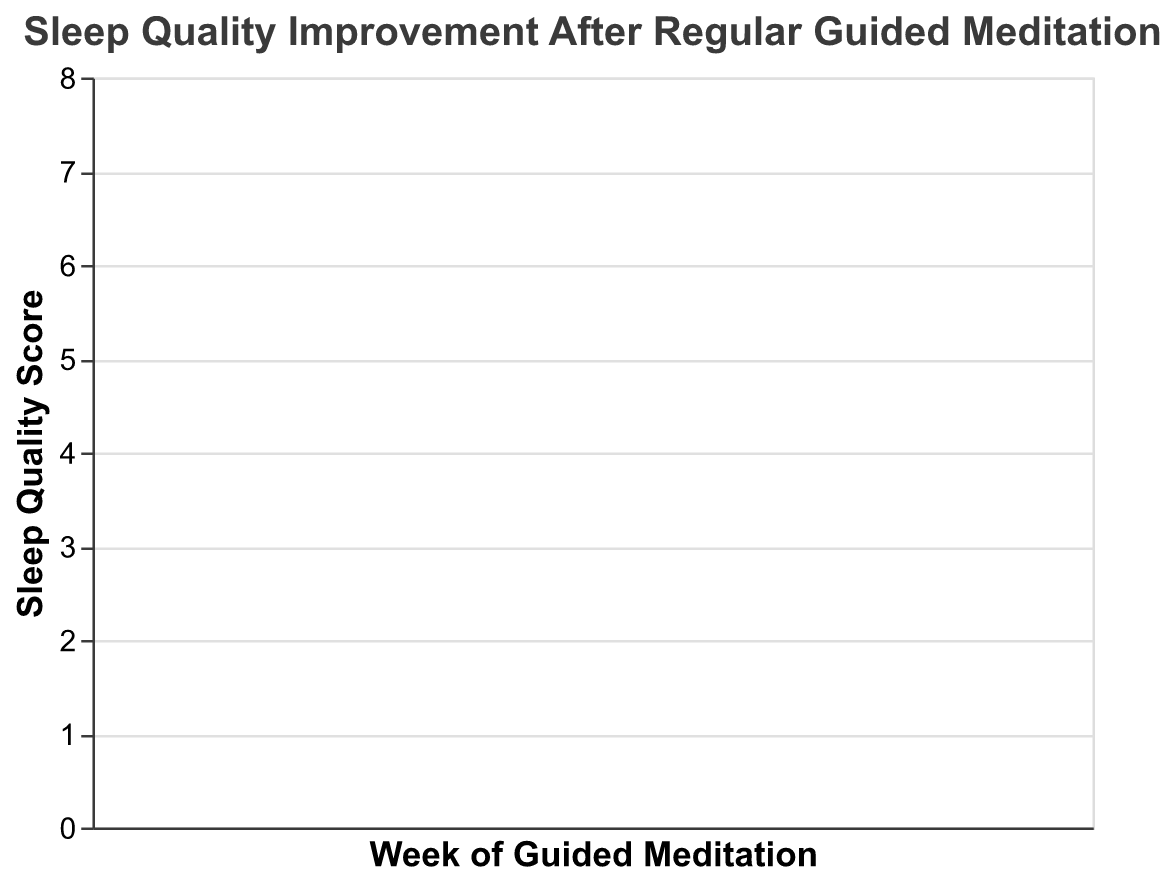What is the title of the figure? Look at the top of the figure. The title is given there.
Answer: Sleep Quality Improvement After Regular Guided Meditation What is being measured on the y-axis? The y-axis title indicates what is being measured.
Answer: Sleep Quality Score How many weeks of data are presented in the figure? Count the distinct labels on the x-axis representing weeks.
Answer: 8 What is the median sleep quality score in Week 5? Find the line within the box for Week 5 which represents the median.
Answer: 5 What is the range of sleep quality scores in Week 1? The range is determined by the minimum and maximum values. Look at the whiskers of the box plot for Week 1.
Answer: 2 to 5 How does the median sleep quality score change from Week 1 to Week 4? Compare the positions of the median lines for Week 1 and Week 4.
Answer: Increases Which week has the smallest interquartile range (IQR)? The IQR is the box length. Look for the week with the smallest box.
Answer: Week 5 or Week 6 Is there any week where the minimum sleep quality score is the same as the median sleep quality score? Check if any weeks have the lower whisker touching the median line.
Answer: No In which week is the median sleep quality score the highest? Identify the week with the highest median line.
Answer: Week 4 What is the trend of sleep quality scores from Week 1 to Week 8? Observe the changes in medians across all weeks.
Answer: Increasing trend 